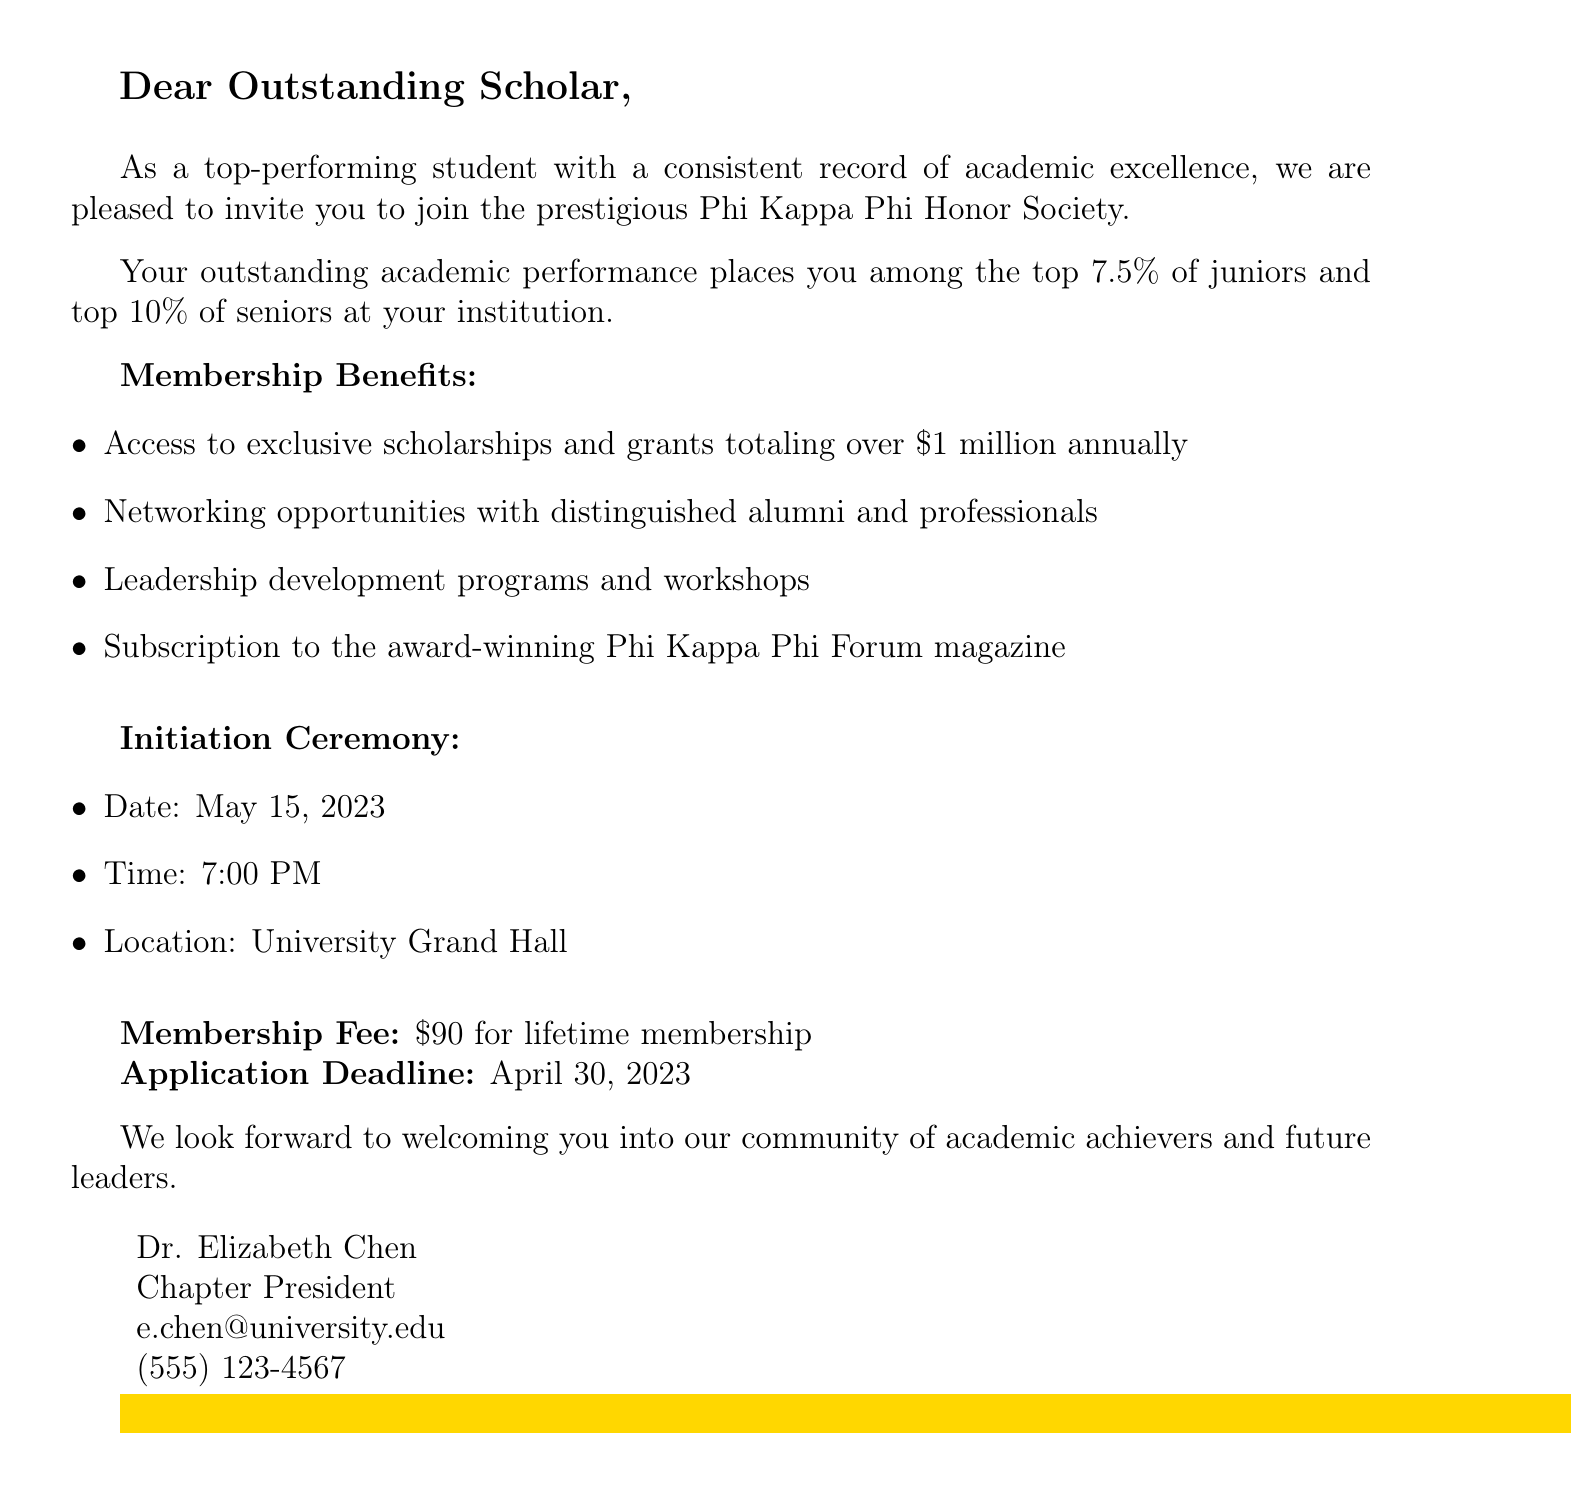What is the name of the honor society? The document invites the recipient to join the Phi Kappa Phi Honor Society, which is the main focus of the invitation.
Answer: Phi Kappa Phi Who sent the invitation? The invitation is signed by the Chapter President, who is Dr. Elizabeth Chen.
Answer: Dr. Elizabeth Chen What is the membership fee? The document specifies that the fee required for membership in the honor society is $90 for lifetime membership.
Answer: $90 What is the application deadline? The invitation states that the deadline to apply for membership is April 30, 2023.
Answer: April 30, 2023 What percentage of students is eligible for membership? The document states that eligibility is based on being among the top 7.5% of juniors and top 10% of seniors at the institution.
Answer: 7.5% juniors and 10% seniors When is the initiation ceremony? The document provides the date for the initiation ceremony, which is May 15, 2023, along with the time and location.
Answer: May 15, 2023 What benefits come with membership? The membership benefits listed include access to scholarships, networking opportunities, leadership development programs, and a magazine subscription.
Answer: Scholarships, networking, leadership programs, magazine What is the location of the initiation ceremony? The ceremony is stated to be held at the University Grand Hall, which is a specific location mentioned in the invitation.
Answer: University Grand Hall How many benefits are listed for membership? The document outlines four specific benefits associated with joining the honor society, indicating the breadth of opportunities offered.
Answer: Four benefits 